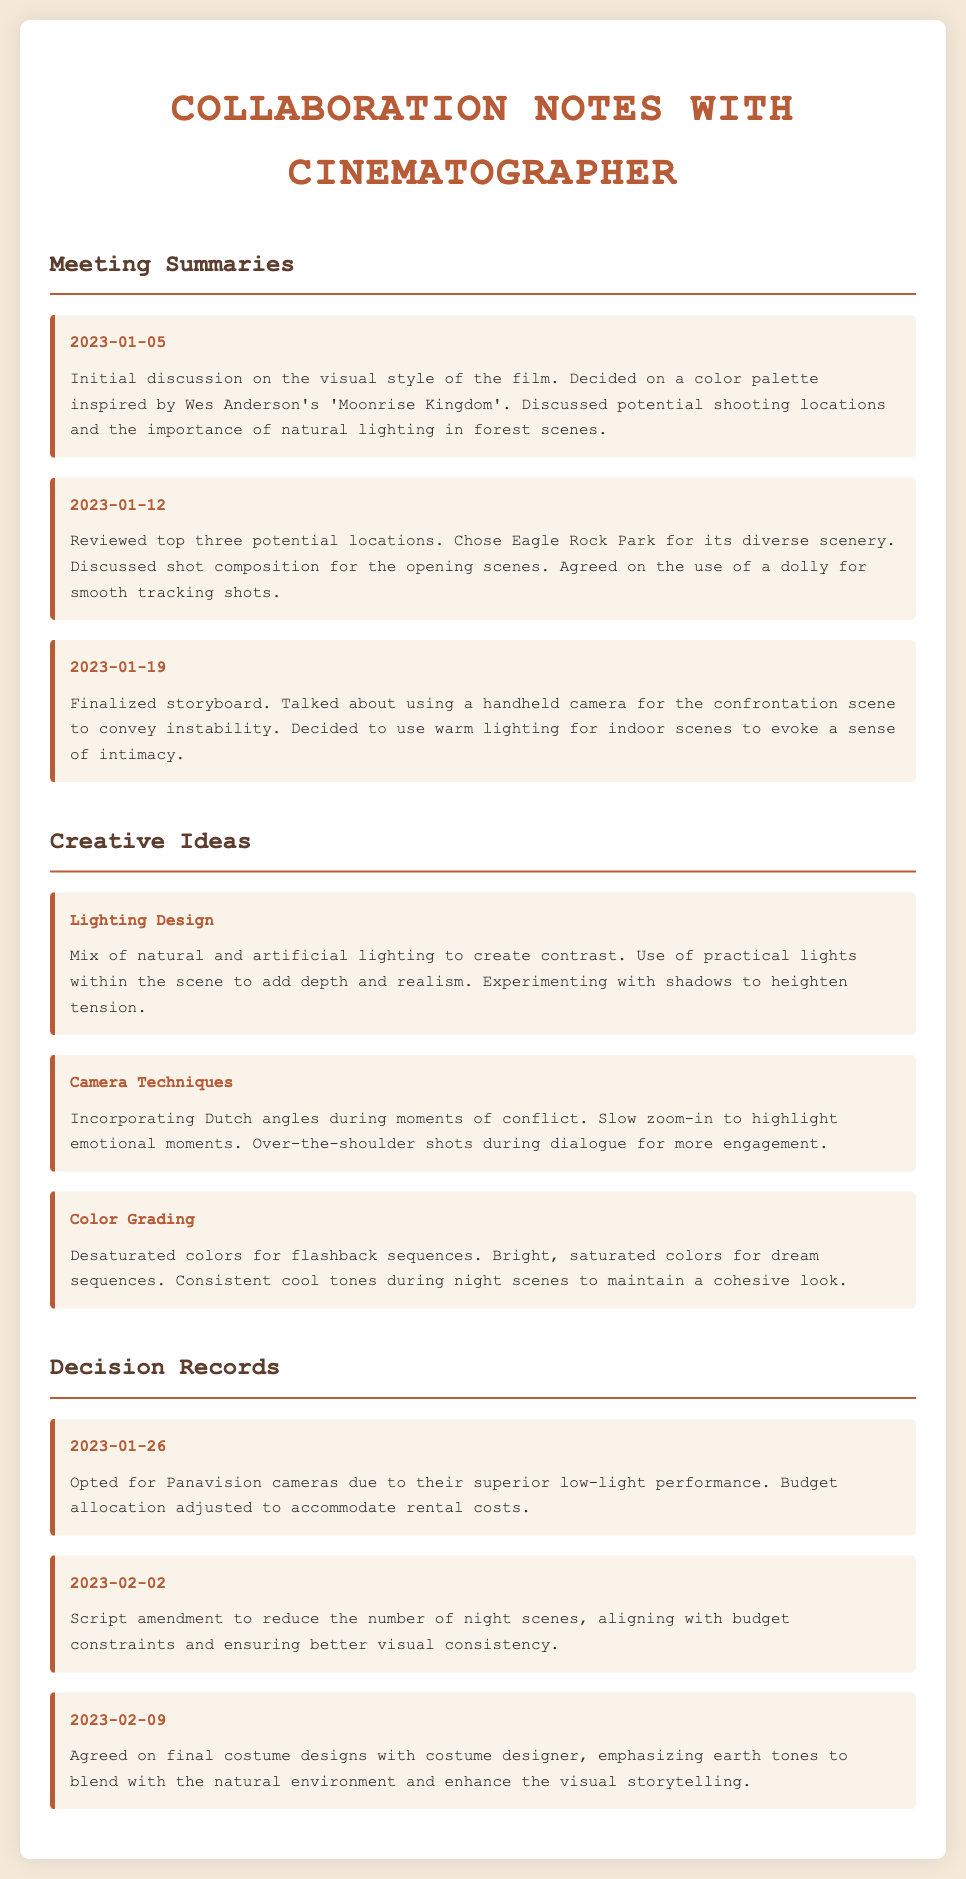What date was the initial discussion on visual style? The date of the initial discussion is indicated in the Meeting Summaries section.
Answer: 2023-01-05 What location was chosen for shooting? The chosen shooting location is listed in the Meeting Summaries.
Answer: Eagle Rock Park What camera type was decided upon? The decision regarding the camera type is documented in the Decision Records section.
Answer: Panavision What lighting technique was proposed for the confrontation scene? The proposed lighting technique for the confrontation scene can be found under Meeting Summaries.
Answer: Handheld camera How many potential locations were reviewed in the second meeting? The number of potential locations reviewed is mentioned in the Meeting Summaries.
Answer: Three What color palette was inspired by a film mentioned in the initial meeting? The color palette inspired by another film is noted in the Meeting Summaries.
Answer: Wes Anderson's 'Moonrise Kingdom' What concept is associated with experimenting with shadows? The concept related to shadows is listed under Creative Ideas.
Answer: Lighting Design What was amended in the script as a decision? The specific change to the script aligns with the decisions documented.
Answer: Reduce the number of night scenes 